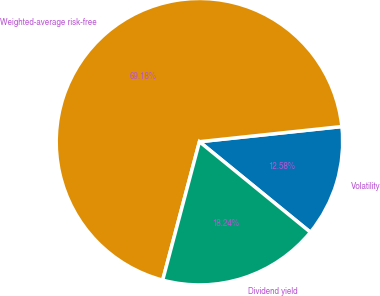<chart> <loc_0><loc_0><loc_500><loc_500><pie_chart><fcel>Volatility<fcel>Weighted-average risk-free<fcel>Dividend yield<nl><fcel>12.58%<fcel>69.18%<fcel>18.24%<nl></chart> 